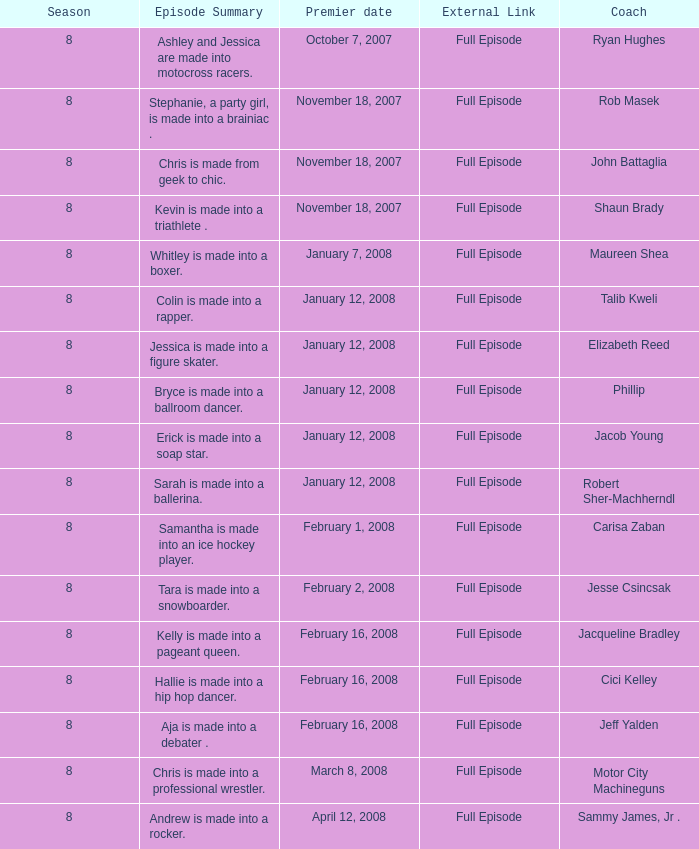Who was the trainer for episode 15? Phillip. 